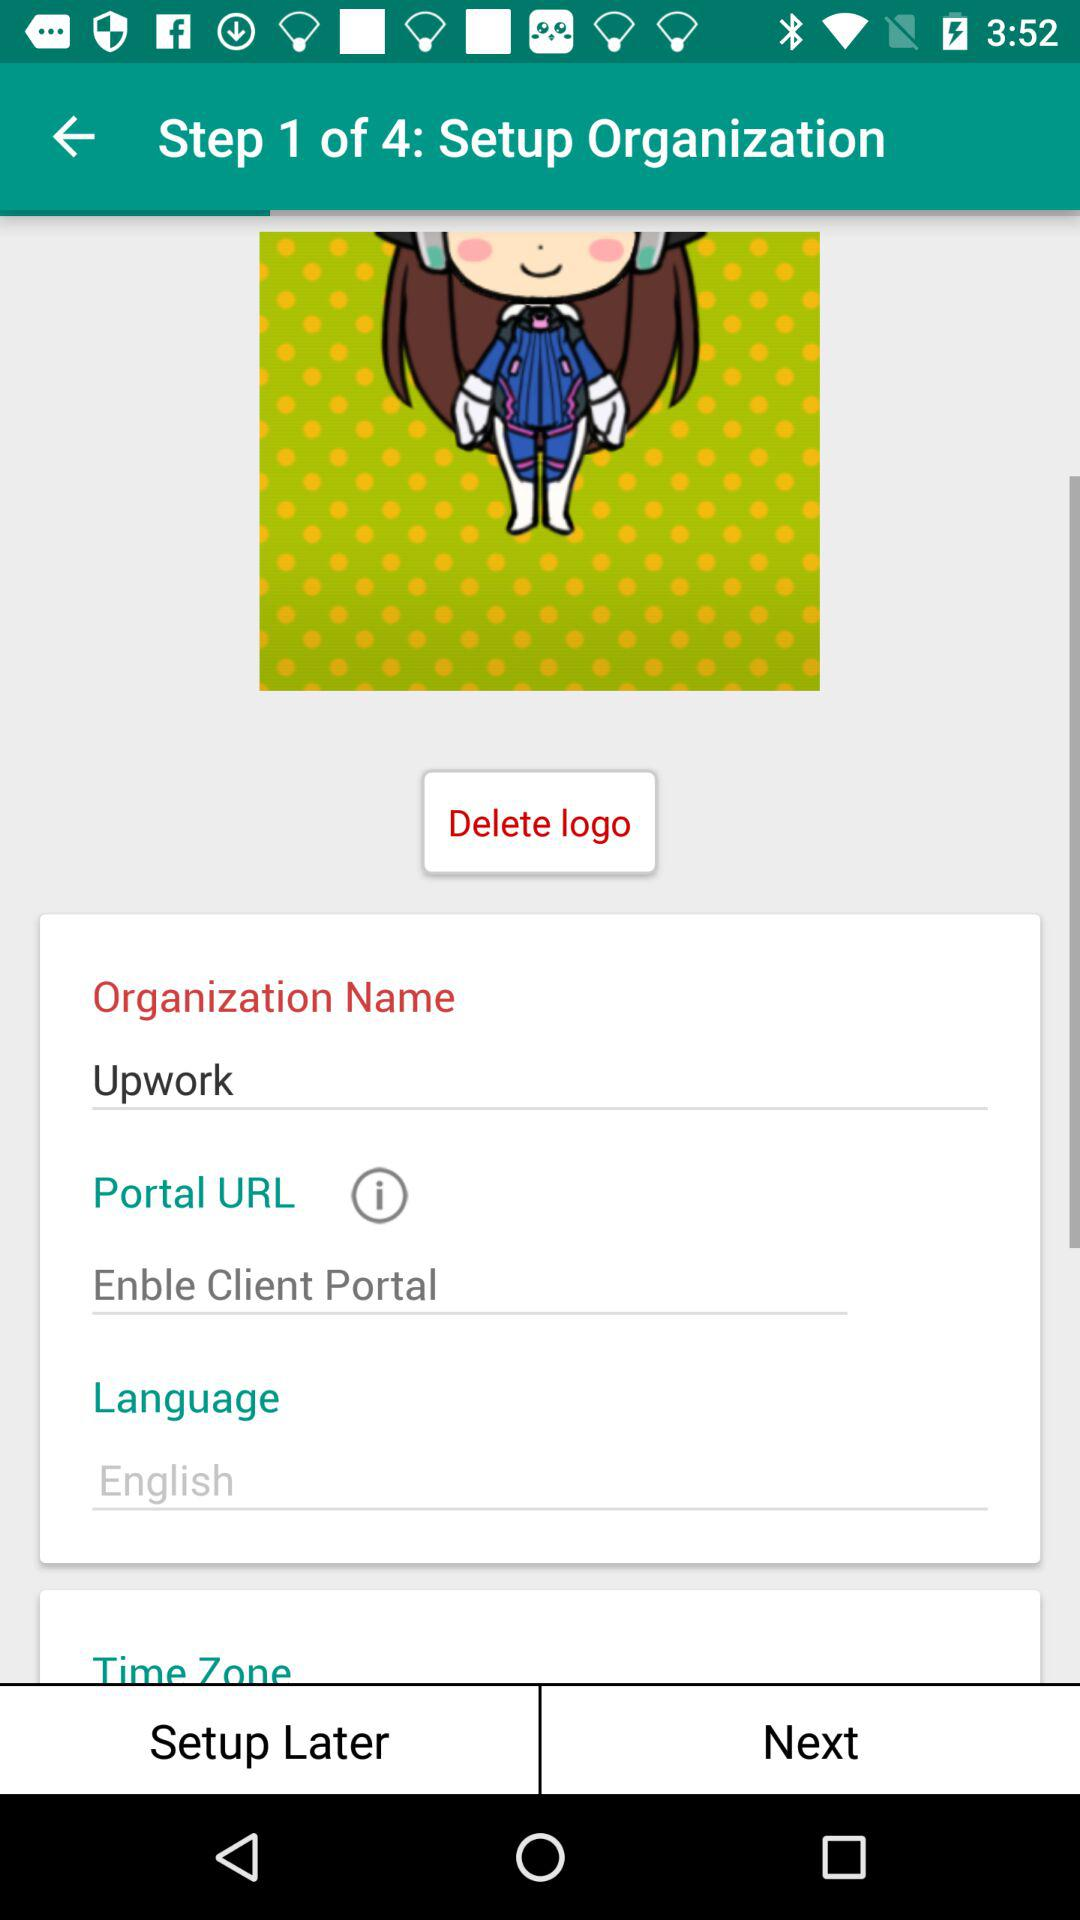What language is mentioned? The mentioned language is English. 